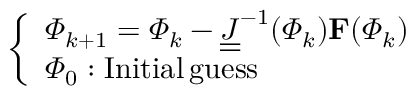<formula> <loc_0><loc_0><loc_500><loc_500>\left \{ \begin{array} { l l } { \varPhi _ { k + 1 } = \varPhi _ { k } - \underline { { \underline { J } } } ^ { - 1 } ( \varPhi _ { k } ) F ( \varPhi _ { k } ) } \\ { \varPhi _ { 0 } \colon I n i t i a l \, g u e s s } \end{array}</formula> 